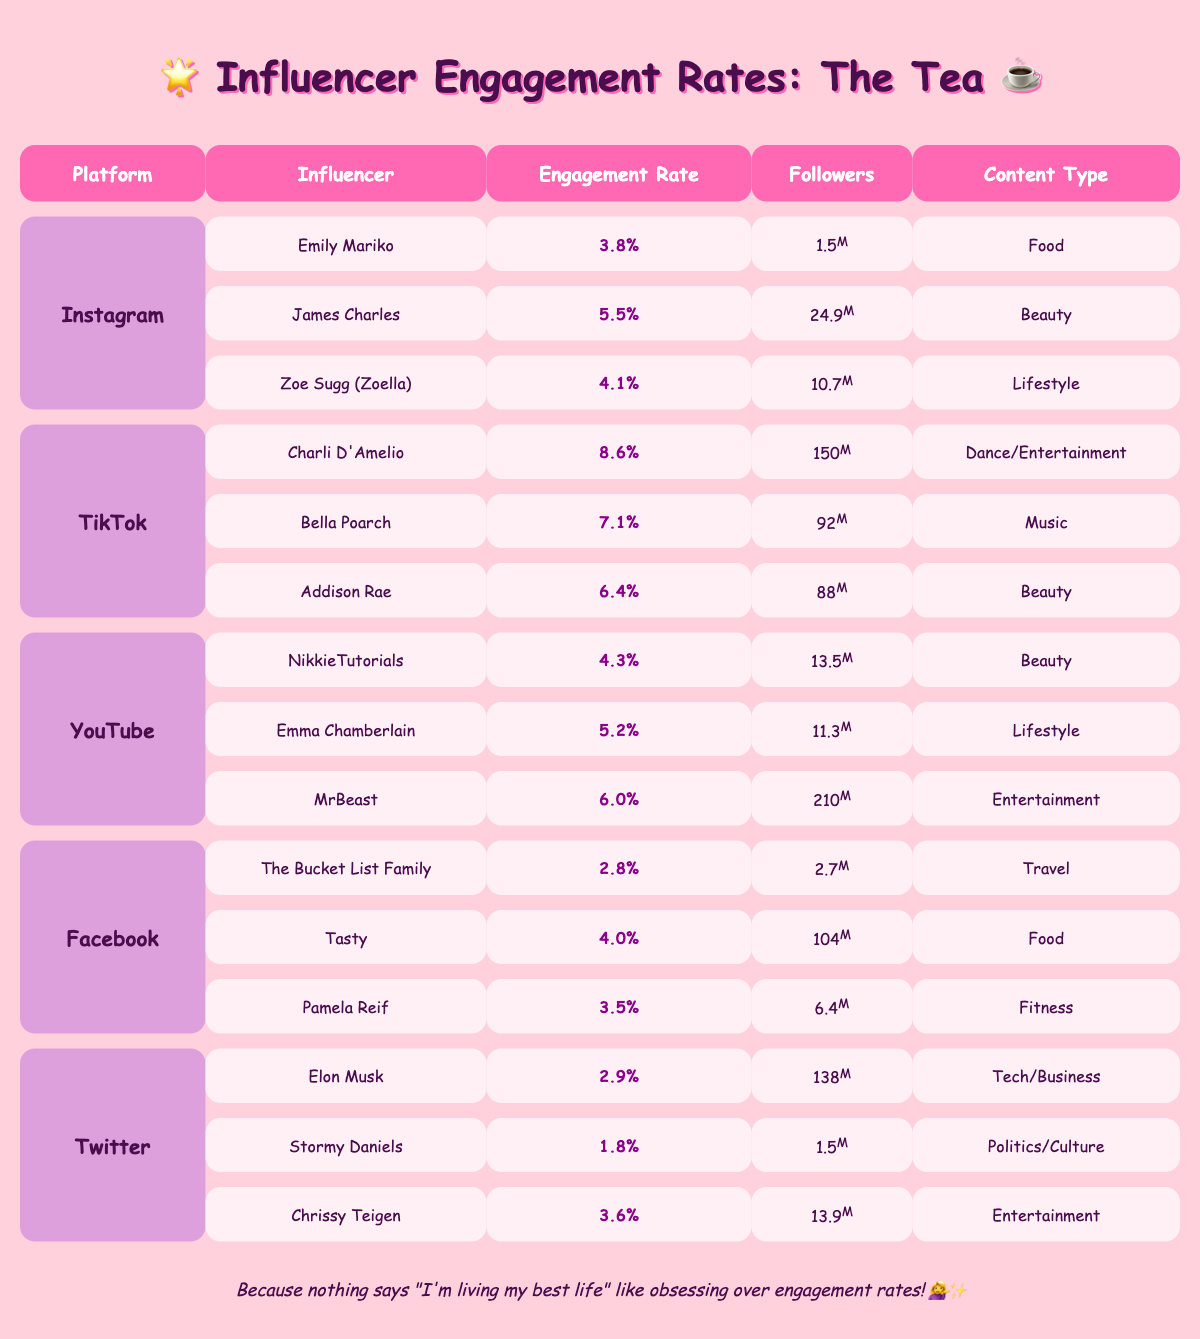What's the engagement rate for James Charles on Instagram? James Charles has an engagement rate of 5.5% listed next to his name under the Instagram section of the table.
Answer: 5.5% Which influencer has the highest engagement rate on TikTok? Charli D'Amelio has the highest engagement rate at 8.6%, as indicated in the TikTok section of the table.
Answer: Charli D'Amelio How many followers does Emily Mariko have? In the Instagram section, Emily Mariko is listed with 1.5 million followers.
Answer: 1.5 million What is the average engagement rate of influencers on YouTube? The engagement rates for YouTube influencers are 4.3% (NikkieTutorials), 5.2% (Emma Chamberlain), and 6.0% (MrBeast). The average is calculated as (4.3 + 5.2 + 6.0) / 3 = 5.17%.
Answer: 5.17% Which platform has the lowest engagement rate for its top influencers? If we look at the engagement rates for each platform, Facebook's highest engagement is 4.0% (Tasty). Therefore, Facebook has the lowest engagement rate among the listed platforms.
Answer: Facebook Is there any influencer on Twitter with an engagement rate above 3%? Among the Twitter influencers listed, Chrissy Teigen has an engagement rate of 3.6%, confirming there are influencers above 3%.
Answer: Yes What’s the total number of followers for top influencers on Instagram? The sum of followers for Instagram influencers is 1.5 million (Emily Mariko) + 24.9 million (James Charles) + 10.7 million (Zoe Sugg) = 37.1 million.
Answer: 37.1 million What content type does the top influencer on TikTok create? Charli D'Amelio, the top influencer on TikTok, produces Dance/Entertainment content, as noted in the table.
Answer: Dance/Entertainment How does Charli D'Amelio's engagement rate compare to the highest engagement rate on Instagram? Charli D'Amelio has an engagement rate of 8.6%, which is higher than James Charles’ highest engagement rate of 5.5% on Instagram.
Answer: Higher Which influencer on Facebook has the highest engagement rate, and how many followers do they have? Tasty has the highest engagement rate on Facebook at 4.0% with 104 million followers, as shown in the Facebook section of the table.
Answer: Tasty, 104 million followers 